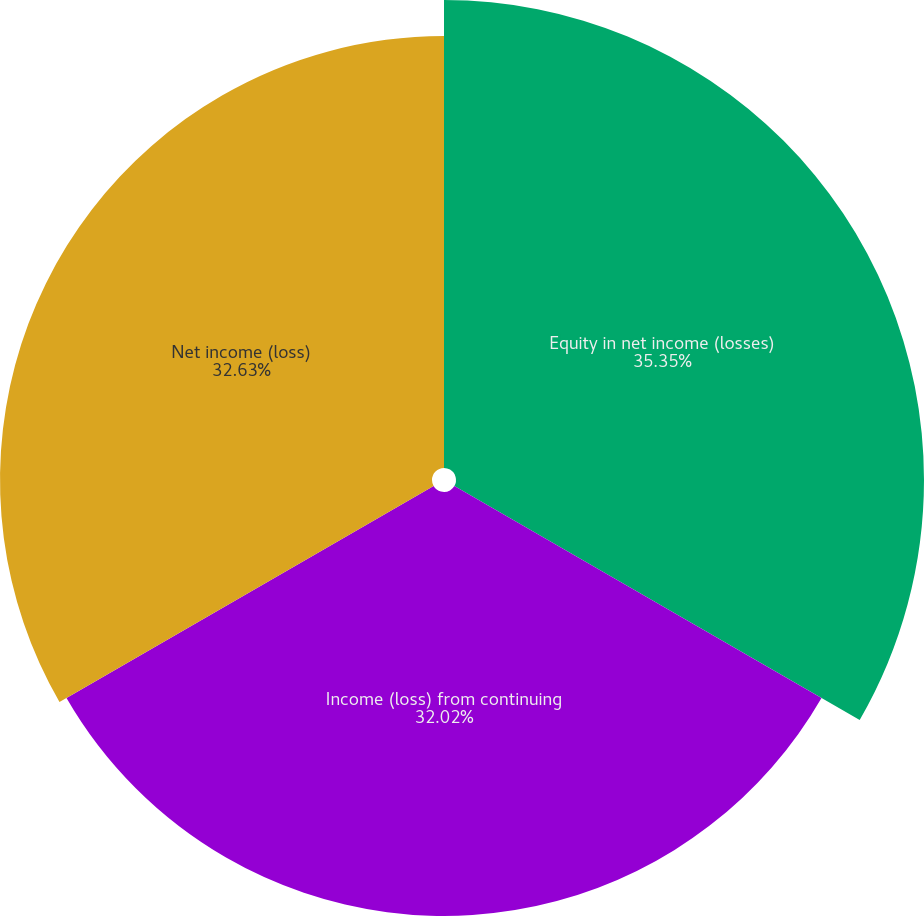Convert chart to OTSL. <chart><loc_0><loc_0><loc_500><loc_500><pie_chart><fcel>Equity in net income (losses)<fcel>Income (loss) from continuing<fcel>Net income (loss)<nl><fcel>35.35%<fcel>32.02%<fcel>32.63%<nl></chart> 